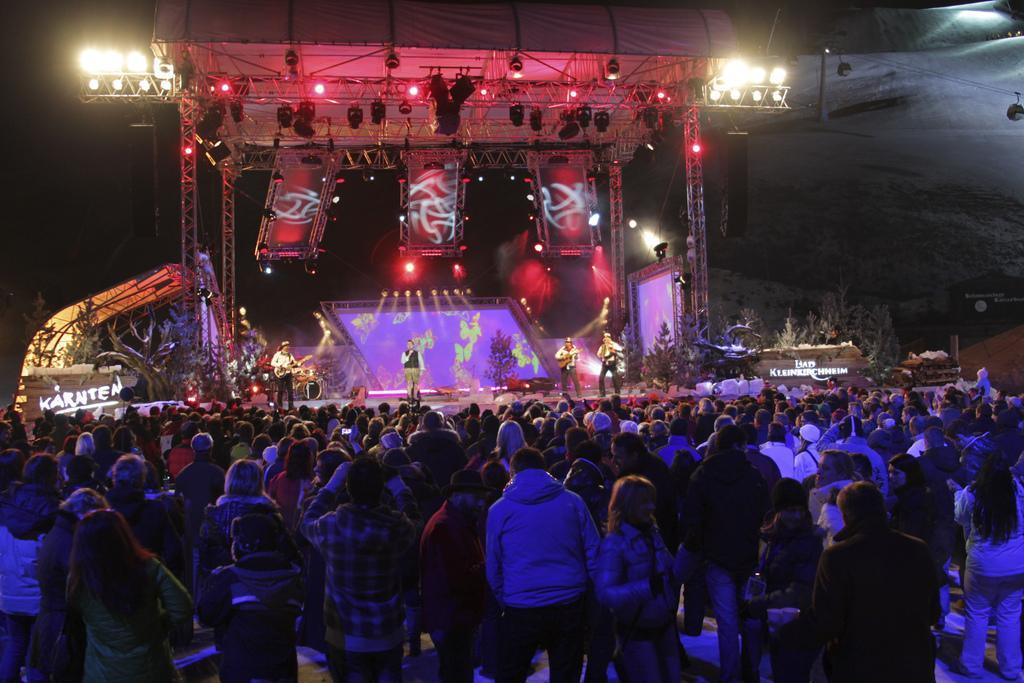Could you give a brief overview of what you see in this image? There are persons in different color dresses standing on the floor. In the background, there are four persons. Two of them are holding musical instruments. One of the rest is holding a mic and standing on a stage, on which there are speakers, plants, lights, a roof and other objects arranged. And the background is dark in color. 